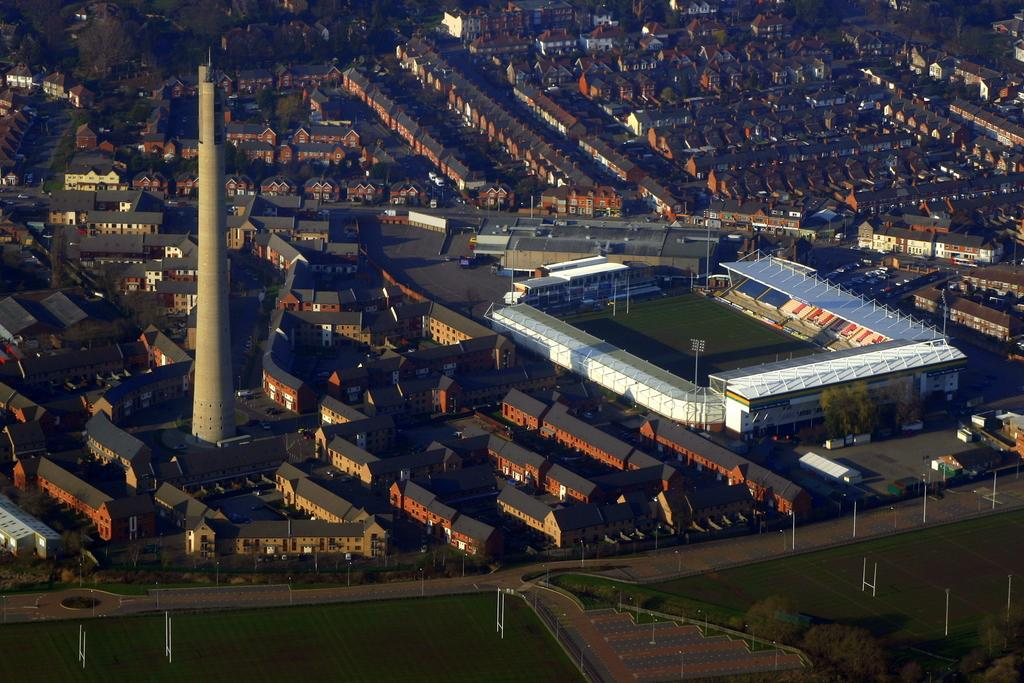What type of view is shown in the image? The image is a top view of a city. What structures can be seen in the image? There are buildings and a tower in the image. Is there any specific sports facility visible in the image? Yes, there is a rugby stadium in the image. What type of toothbrush is used by the people in the image? There is no toothbrush present in the image, as it is a top view of a city with buildings, a tower, and a rugby stadium. What kind of furniture can be seen in the image? The image is a top view of a city, so there is no furniture visible. 